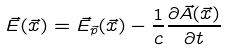<formula> <loc_0><loc_0><loc_500><loc_500>\vec { E } ( \vec { x } ) = \vec { E } _ { \vec { p } } ( \vec { x } ) - \frac { 1 } { c } \frac { \partial \vec { A } ( \vec { x } ) } { \partial t }</formula> 